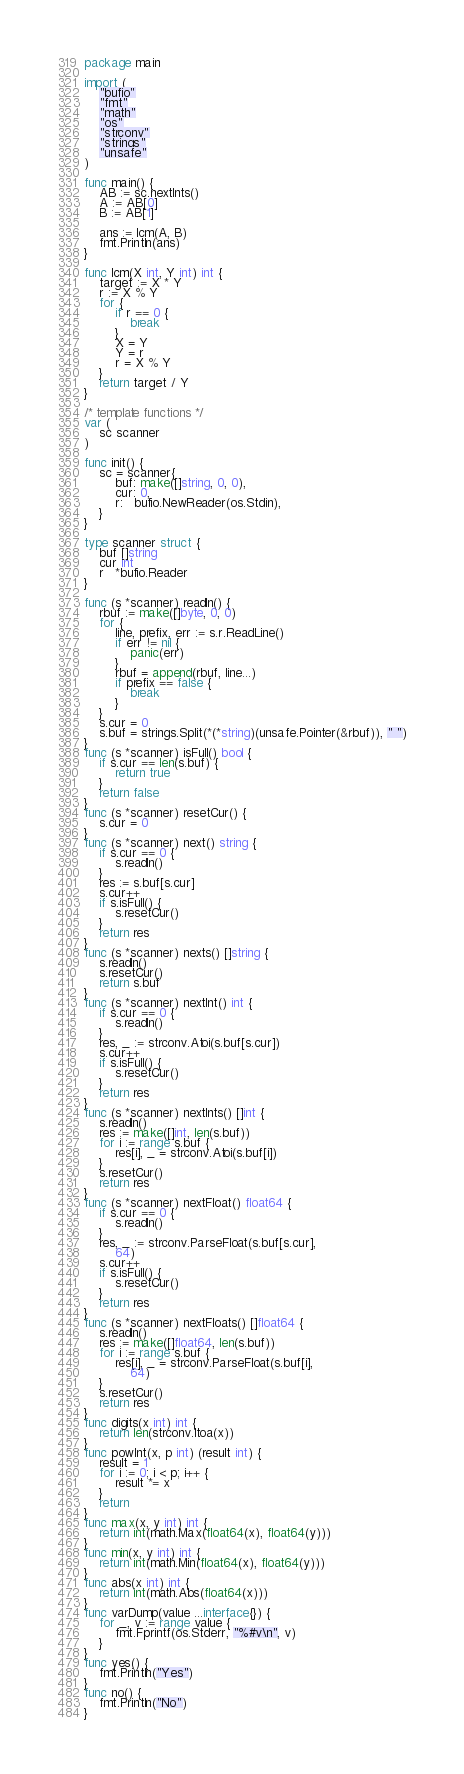Convert code to text. <code><loc_0><loc_0><loc_500><loc_500><_Go_>package main

import (
	"bufio"
	"fmt"
	"math"
	"os"
	"strconv"
	"strings"
	"unsafe"
)

func main() {
	AB := sc.nextInts()
	A := AB[0]
	B := AB[1]

	ans := lcm(A, B)
	fmt.Println(ans)
}

func lcm(X int, Y int) int {
	target := X * Y
	r := X % Y
	for {
		if r == 0 {
			break
		}
		X = Y
		Y = r
		r = X % Y
	}
	return target / Y
}

/* template functions */
var (
	sc scanner
)

func init() {
	sc = scanner{
		buf: make([]string, 0, 0),
		cur: 0,
		r:   bufio.NewReader(os.Stdin),
	}
}

type scanner struct {
	buf []string
	cur int
	r   *bufio.Reader
}

func (s *scanner) readln() {
	rbuf := make([]byte, 0, 0)
	for {
		line, prefix, err := s.r.ReadLine()
		if err != nil {
			panic(err)
		}
		rbuf = append(rbuf, line...)
		if prefix == false {
			break
		}
	}
	s.cur = 0
	s.buf = strings.Split(*(*string)(unsafe.Pointer(&rbuf)), " ")
}
func (s *scanner) isFull() bool {
	if s.cur == len(s.buf) {
		return true
	}
	return false
}
func (s *scanner) resetCur() {
	s.cur = 0
}
func (s *scanner) next() string {
	if s.cur == 0 {
		s.readln()
	}
	res := s.buf[s.cur]
	s.cur++
	if s.isFull() {
		s.resetCur()
	}
	return res
}
func (s *scanner) nexts() []string {
	s.readln()
	s.resetCur()
	return s.buf
}
func (s *scanner) nextInt() int {
	if s.cur == 0 {
		s.readln()
	}
	res, _ := strconv.Atoi(s.buf[s.cur])
	s.cur++
	if s.isFull() {
		s.resetCur()
	}
	return res
}
func (s *scanner) nextInts() []int {
	s.readln()
	res := make([]int, len(s.buf))
	for i := range s.buf {
		res[i], _ = strconv.Atoi(s.buf[i])
	}
	s.resetCur()
	return res
}
func (s *scanner) nextFloat() float64 {
	if s.cur == 0 {
		s.readln()
	}
	res, _ := strconv.ParseFloat(s.buf[s.cur],
		64)
	s.cur++
	if s.isFull() {
		s.resetCur()
	}
	return res
}
func (s *scanner) nextFloats() []float64 {
	s.readln()
	res := make([]float64, len(s.buf))
	for i := range s.buf {
		res[i], _ = strconv.ParseFloat(s.buf[i],
			64)
	}
	s.resetCur()
	return res
}
func digits(x int) int {
	return len(strconv.Itoa(x))
}
func powInt(x, p int) (result int) {
	result = 1
	for i := 0; i < p; i++ {
		result *= x
	}
	return
}
func max(x, y int) int {
	return int(math.Max(float64(x), float64(y)))
}
func min(x, y int) int {
	return int(math.Min(float64(x), float64(y)))
}
func abs(x int) int {
	return int(math.Abs(float64(x)))
}
func varDump(value ...interface{}) {
	for _, v := range value {
		fmt.Fprintf(os.Stderr, "%#v\n", v)
	}
}
func yes() {
	fmt.Println("Yes")
}
func no() {
	fmt.Println("No")
}
</code> 